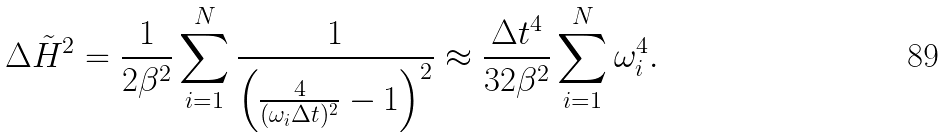Convert formula to latex. <formula><loc_0><loc_0><loc_500><loc_500>\Delta \tilde { H } ^ { 2 } = \frac { 1 } { 2 \beta ^ { 2 } } \sum _ { i = 1 } ^ { N } \frac { 1 } { \left ( \frac { 4 } { ( \omega _ { i } \Delta t ) ^ { 2 } } - 1 \right ) ^ { 2 } } \approx \frac { \Delta t ^ { 4 } } { 3 2 \beta ^ { 2 } } \sum _ { i = 1 } ^ { N } \omega _ { i } ^ { 4 } .</formula> 